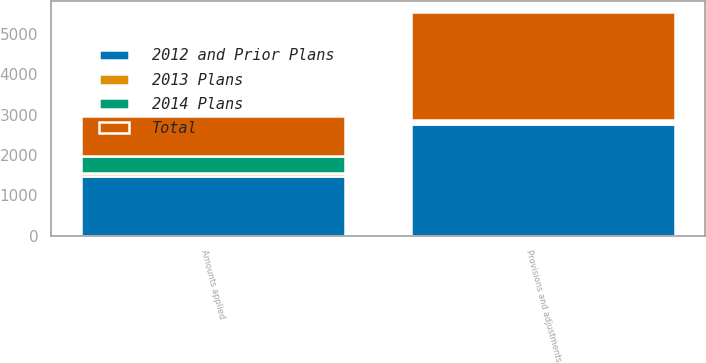Convert chart. <chart><loc_0><loc_0><loc_500><loc_500><stacked_bar_chart><ecel><fcel>Provisions and adjustments<fcel>Amounts applied<nl><fcel>2013 Plans<fcel>41<fcel>74<nl><fcel>2014 Plans<fcel>57<fcel>407<nl><fcel>Total<fcel>2672<fcel>1002<nl><fcel>2012 and Prior Plans<fcel>2770<fcel>1483<nl></chart> 